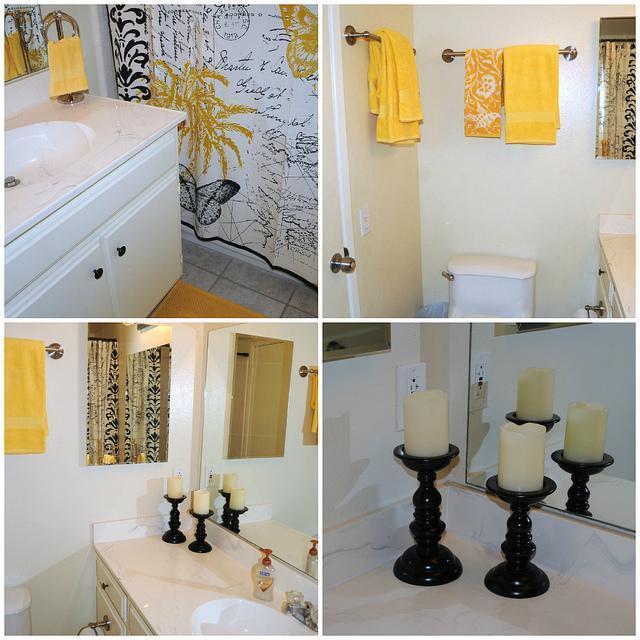How many candles are in the bathroom?
Give a very brief answer. 2. How many sinks are there?
Give a very brief answer. 2. 